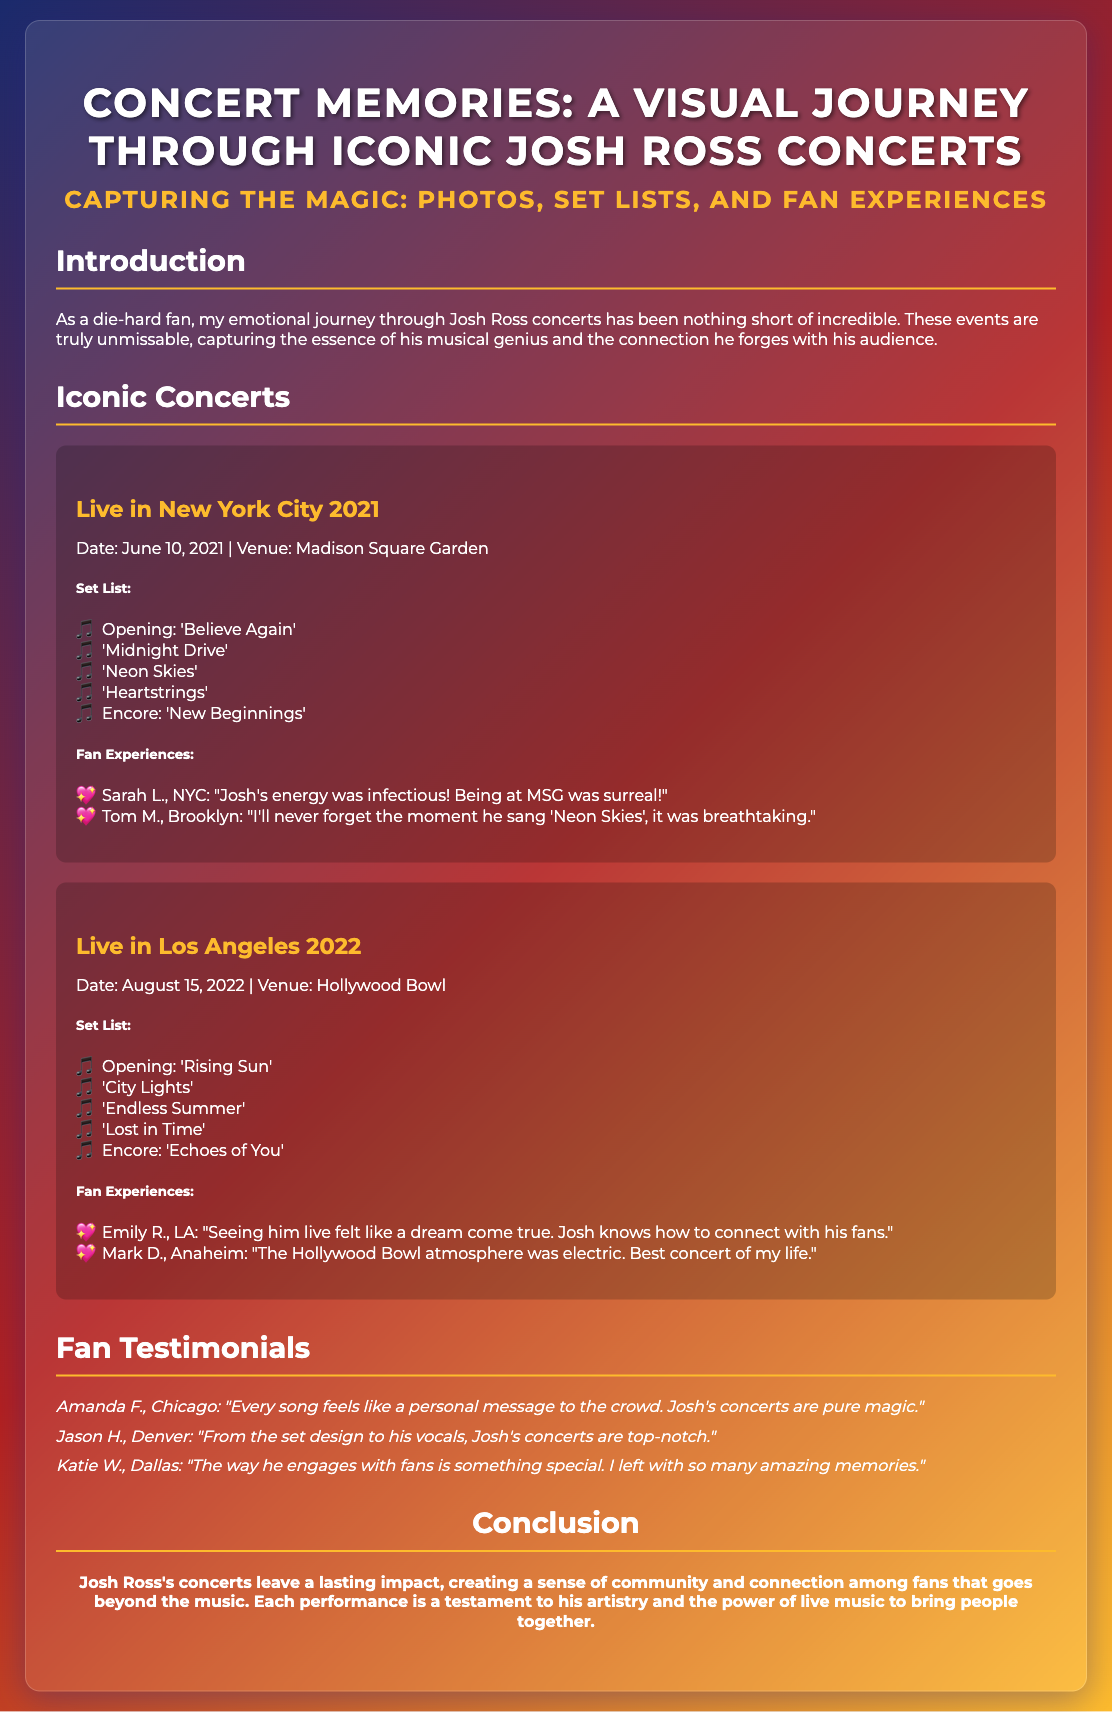what is the title of the presentation? The title of the presentation is found at the top of the document.
Answer: Concert Memories: A Visual Journey Through Iconic Josh Ross Concerts how many concerts are featured in the presentation? The presentation lists two concerts in the Iconic Concerts section.
Answer: 2 what was the date of the concert in New York City? The date of the New York City concert is mentioned in the first concert's details.
Answer: June 10, 2021 which song opened the Los Angeles concert? The opening song for the Los Angeles concert is under the Set List section for that concert.
Answer: Rising Sun who gave a testimonial stating that every song feels like a personal message? The testimonial is attributed to a specific fan who shared their experience.
Answer: Amanda F., Chicago what was the venue of the concert in Los Angeles? The venue for the Los Angeles concert is specified in the concert details.
Answer: Hollywood Bowl what is one word that describes Josh's concerts according to a fan testimonial? A keyword related to the emotional impact of his concerts is included in the testimonials section.
Answer: Magic which section summarizes the impact of Josh Ross concerts? The conclusion summarizes the overall theme and impact of the concerts.
Answer: Conclusion 